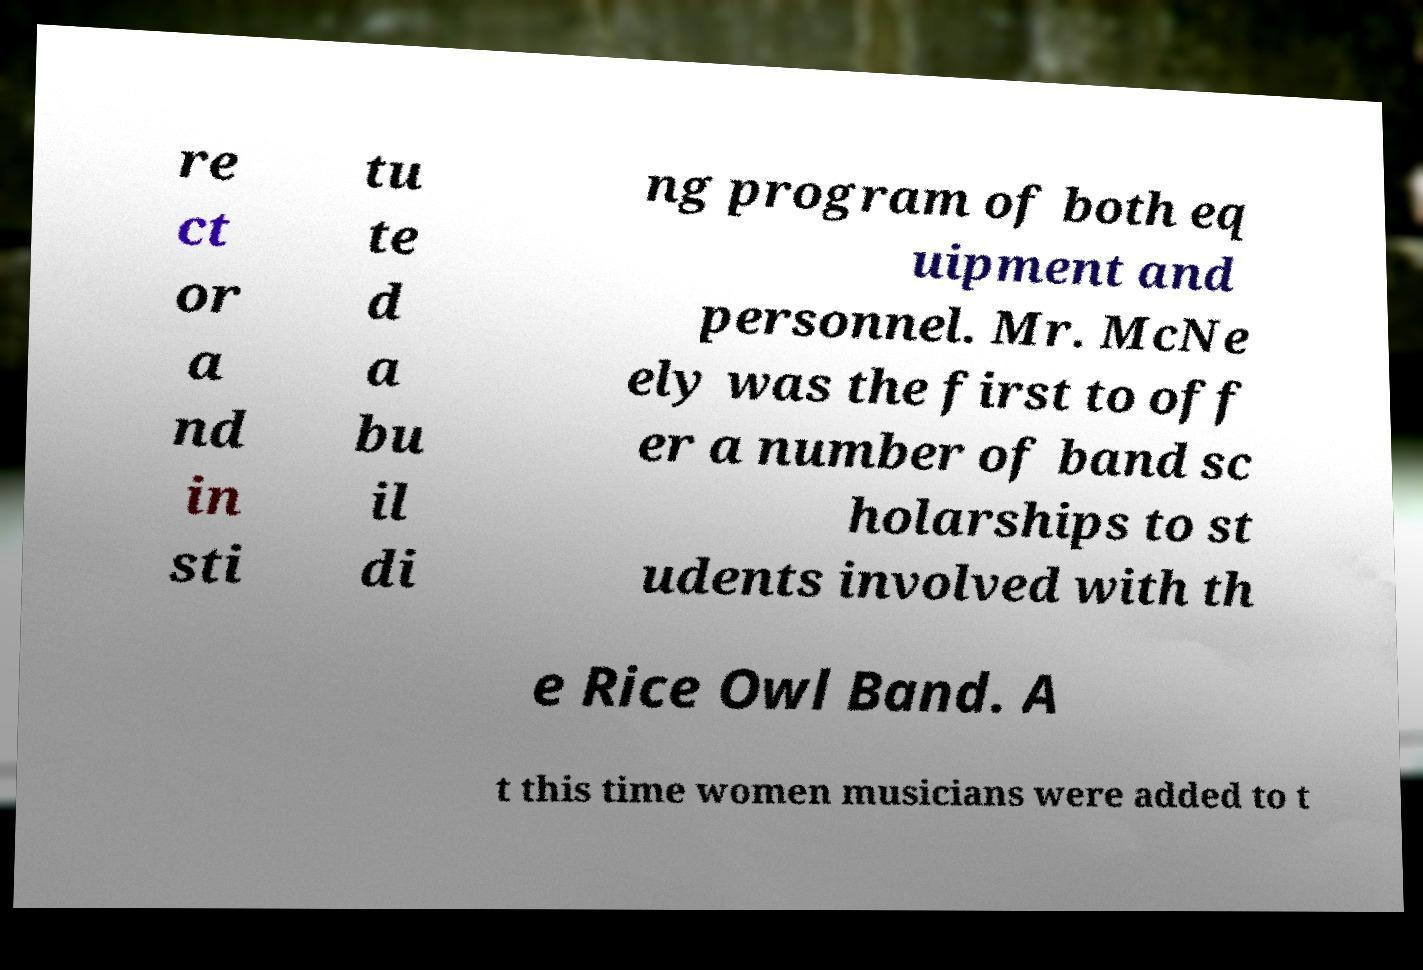What messages or text are displayed in this image? I need them in a readable, typed format. re ct or a nd in sti tu te d a bu il di ng program of both eq uipment and personnel. Mr. McNe ely was the first to off er a number of band sc holarships to st udents involved with th e Rice Owl Band. A t this time women musicians were added to t 